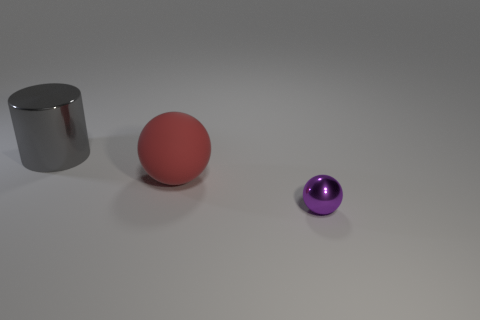Add 1 purple balls. How many objects exist? 4 Subtract all spheres. How many objects are left? 1 Subtract all red rubber balls. Subtract all gray cubes. How many objects are left? 2 Add 2 large balls. How many large balls are left? 3 Add 2 purple shiny spheres. How many purple shiny spheres exist? 3 Subtract 0 green blocks. How many objects are left? 3 